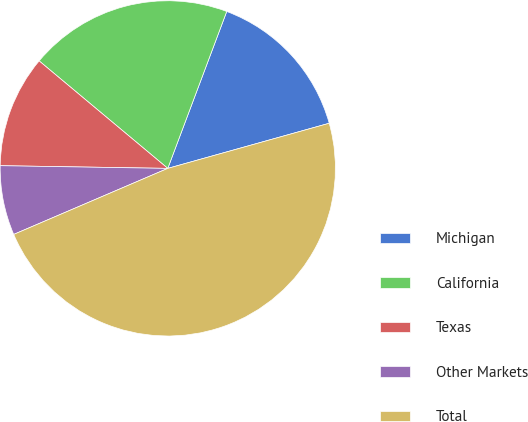Convert chart. <chart><loc_0><loc_0><loc_500><loc_500><pie_chart><fcel>Michigan<fcel>California<fcel>Texas<fcel>Other Markets<fcel>Total<nl><fcel>14.94%<fcel>19.64%<fcel>10.82%<fcel>6.7%<fcel>47.89%<nl></chart> 